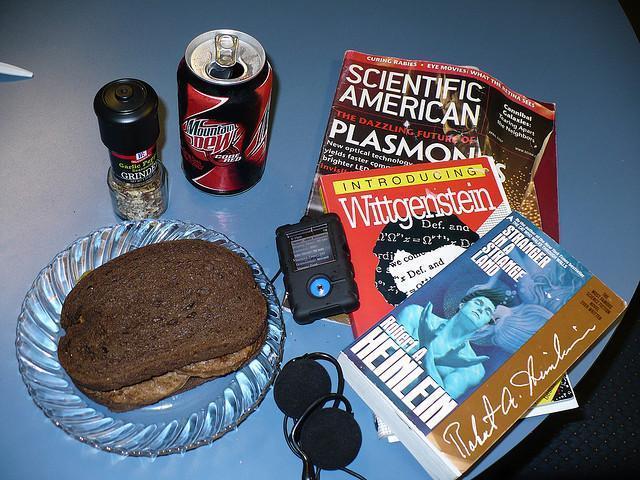How many books are there?
Give a very brief answer. 2. How many different colors is the girl wearing?
Give a very brief answer. 0. 